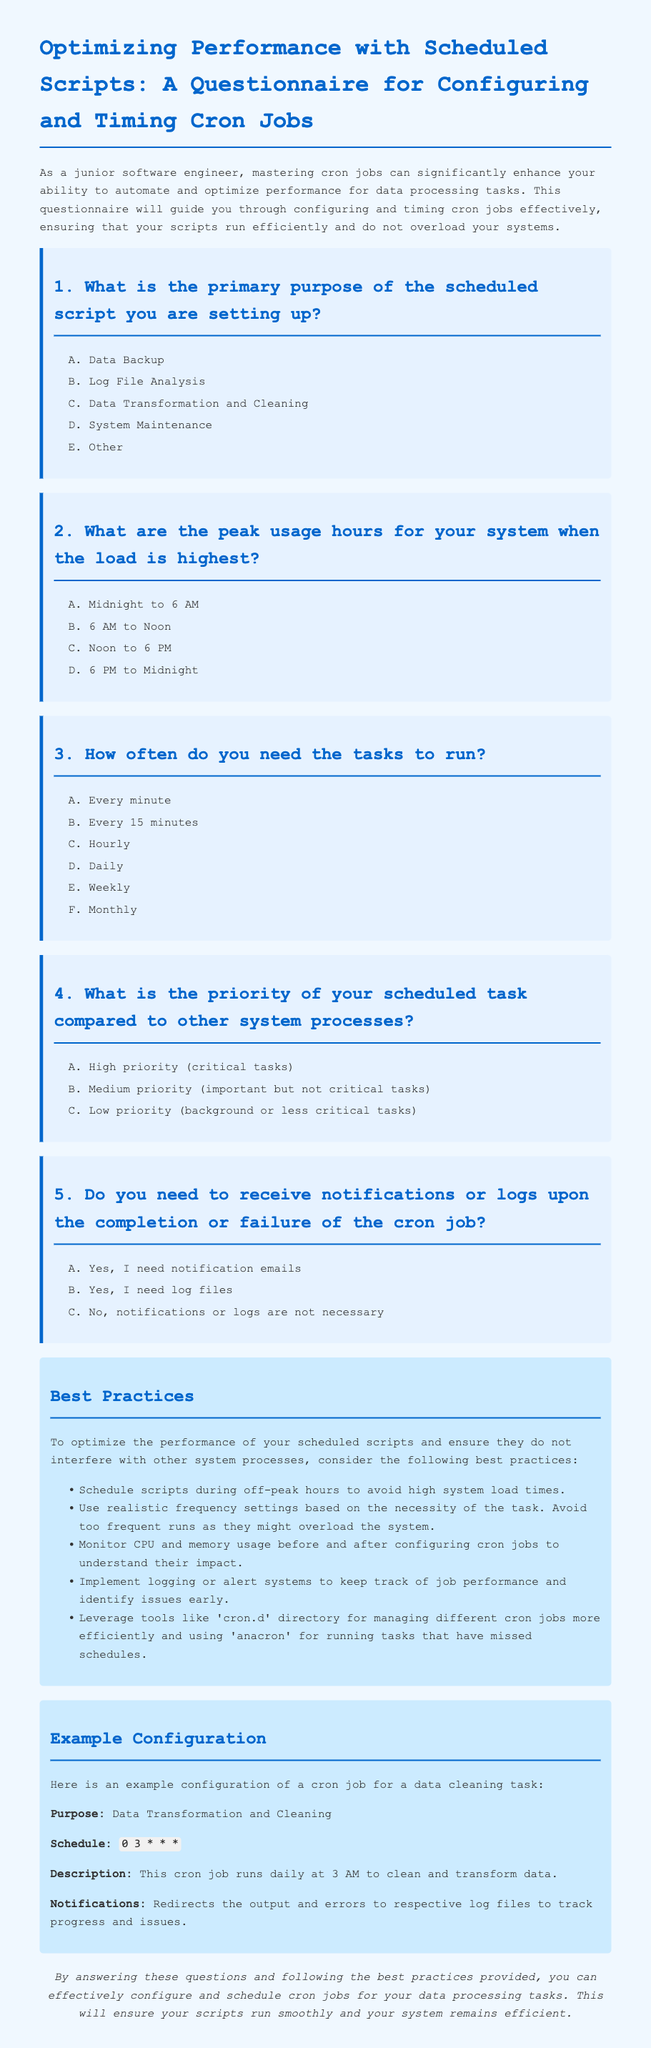What is the primary purpose of the scheduled script? The options for the primary purpose of the scheduled script include data backup, log file analysis, data transformation and cleaning, system maintenance, and others.
Answer: Data Transformation and Cleaning What are the peak usage hours for the system? The document lists four options for peak usage hours: Midnight to 6 AM, 6 AM to Noon, Noon to 6 PM, and 6 PM to Midnight.
Answer: 6 PM to Midnight How often can the tasks be scheduled to run? The document provides options that include every minute, every 15 minutes, hourly, daily, weekly, and monthly.
Answer: Daily What is the highest priority level for a scheduled task? The priority levels listed in the document are high priority, medium priority, and low priority.
Answer: High priority Do you need notifications upon job completion? The options regarding notifications include yes for email notifications, yes for log files, and no notifications are necessary.
Answer: Yes, I need notification emails 